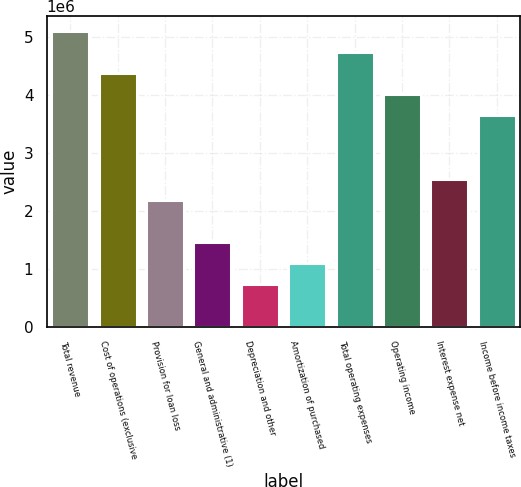Convert chart to OTSL. <chart><loc_0><loc_0><loc_500><loc_500><bar_chart><fcel>Total revenue<fcel>Cost of operations (exclusive<fcel>Provision for loan loss<fcel>General and administrative (1)<fcel>Depreciation and other<fcel>Amortization of purchased<fcel>Total operating expenses<fcel>Operating income<fcel>Interest expense net<fcel>Income before income taxes<nl><fcel>5.09794e+06<fcel>4.36967e+06<fcel>2.18484e+06<fcel>1.45656e+06<fcel>728283<fcel>1.09242e+06<fcel>4.7338e+06<fcel>4.00553e+06<fcel>2.54897e+06<fcel>3.64139e+06<nl></chart> 